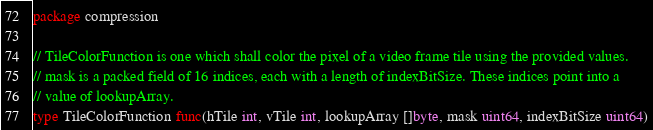<code> <loc_0><loc_0><loc_500><loc_500><_Go_>package compression

// TileColorFunction is one which shall color the pixel of a video frame tile using the provided values.
// mask is a packed field of 16 indices, each with a length of indexBitSize. These indices point into a
// value of lookupArray.
type TileColorFunction func(hTile int, vTile int, lookupArray []byte, mask uint64, indexBitSize uint64)
</code> 